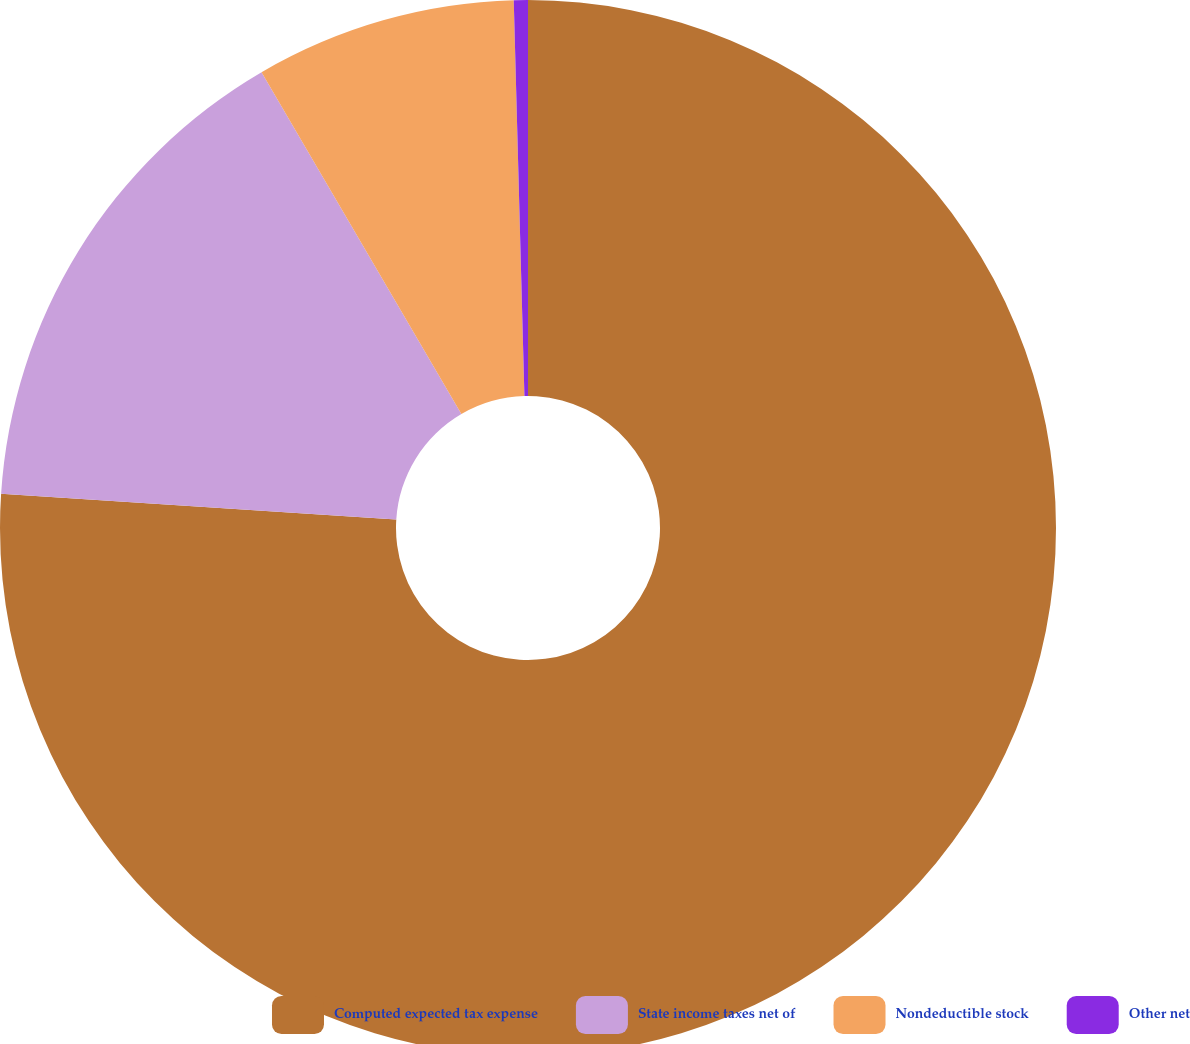Convert chart. <chart><loc_0><loc_0><loc_500><loc_500><pie_chart><fcel>Computed expected tax expense<fcel>State income taxes net of<fcel>Nondeductible stock<fcel>Other net<nl><fcel>76.04%<fcel>15.55%<fcel>7.99%<fcel>0.43%<nl></chart> 